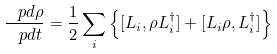<formula> <loc_0><loc_0><loc_500><loc_500>\frac { \ p d { \rho } } { \ p d t } = \frac { 1 } { 2 } \sum _ { i } \left \{ [ L _ { i } , \rho L _ { i } ^ { \dag } ] + [ L _ { i } \rho , L _ { i } ^ { \dag } ] \right \}</formula> 